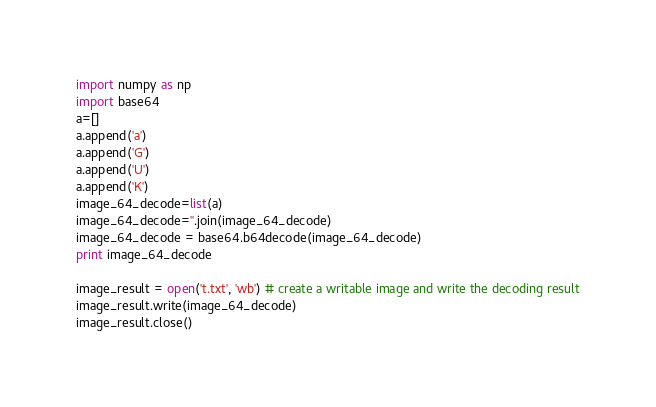<code> <loc_0><loc_0><loc_500><loc_500><_Python_>import numpy as np
import base64
a=[]
a.append('a')
a.append('G')
a.append('U')
a.append('K')
image_64_decode=list(a)
image_64_decode=''.join(image_64_decode)
image_64_decode = base64.b64decode(image_64_decode)
print image_64_decode

image_result = open('t.txt', 'wb') # create a writable image and write the decoding result
image_result.write(image_64_decode)
image_result.close()</code> 